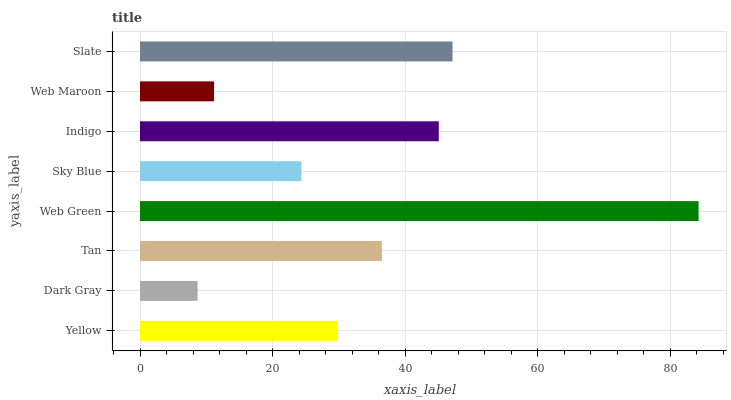Is Dark Gray the minimum?
Answer yes or no. Yes. Is Web Green the maximum?
Answer yes or no. Yes. Is Tan the minimum?
Answer yes or no. No. Is Tan the maximum?
Answer yes or no. No. Is Tan greater than Dark Gray?
Answer yes or no. Yes. Is Dark Gray less than Tan?
Answer yes or no. Yes. Is Dark Gray greater than Tan?
Answer yes or no. No. Is Tan less than Dark Gray?
Answer yes or no. No. Is Tan the high median?
Answer yes or no. Yes. Is Yellow the low median?
Answer yes or no. Yes. Is Dark Gray the high median?
Answer yes or no. No. Is Slate the low median?
Answer yes or no. No. 